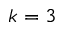Convert formula to latex. <formula><loc_0><loc_0><loc_500><loc_500>k = 3</formula> 